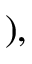Convert formula to latex. <formula><loc_0><loc_0><loc_500><loc_500>) ,</formula> 